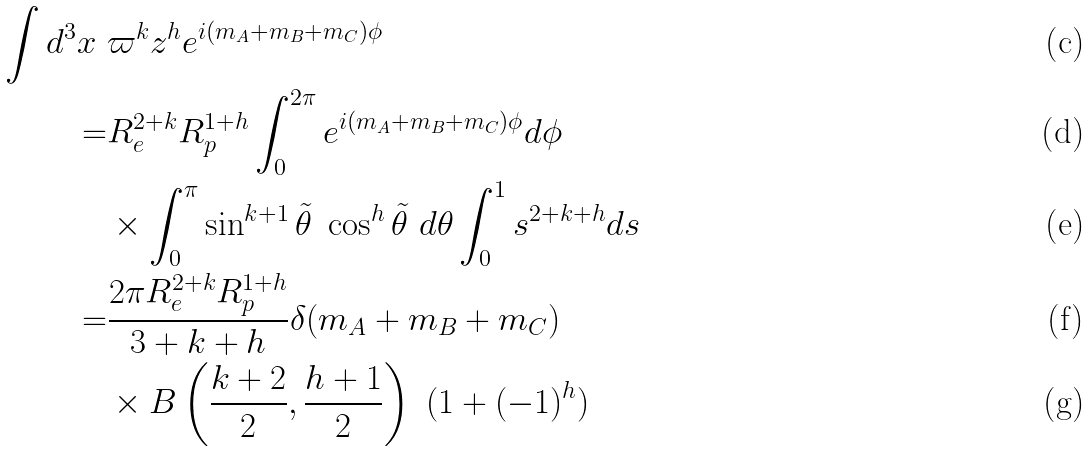Convert formula to latex. <formula><loc_0><loc_0><loc_500><loc_500>\int d ^ { 3 } x \ & \varpi ^ { k } z ^ { h } e ^ { i ( m _ { A } + m _ { B } + m _ { C } ) \phi } \\ = & R _ { e } ^ { 2 + k } R _ { p } ^ { 1 + h } \int _ { 0 } ^ { 2 \pi } e ^ { i ( m _ { A } + m _ { B } + m _ { C } ) \phi } d \phi \\ & \times \int _ { 0 } ^ { \pi } \sin ^ { k + 1 } \tilde { \theta } \ \cos ^ { h } \tilde { \theta } \ d \theta \int _ { 0 } ^ { 1 } s ^ { 2 + k + h } d s \\ = & \frac { 2 \pi R _ { e } ^ { 2 + k } R _ { p } ^ { 1 + h } } { 3 + k + h } \delta ( m _ { A } + m _ { B } + m _ { C } ) \\ & \times B \left ( \frac { k + 2 } { 2 } , \frac { h + 1 } { 2 } \right ) \ ( 1 + ( - 1 ) ^ { h } )</formula> 